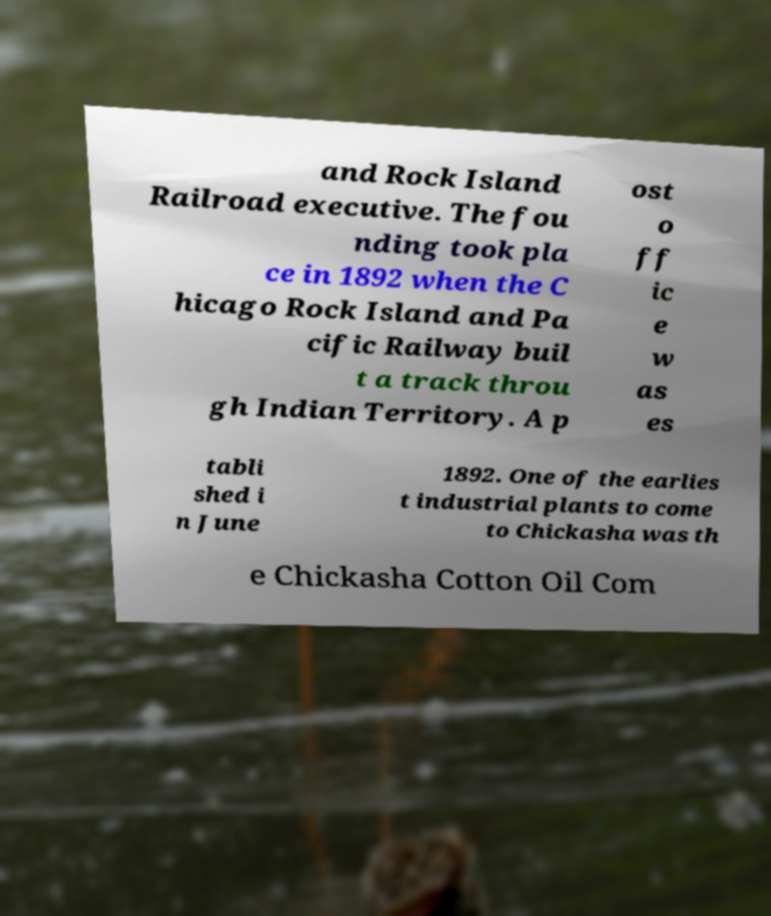What messages or text are displayed in this image? I need them in a readable, typed format. and Rock Island Railroad executive. The fou nding took pla ce in 1892 when the C hicago Rock Island and Pa cific Railway buil t a track throu gh Indian Territory. A p ost o ff ic e w as es tabli shed i n June 1892. One of the earlies t industrial plants to come to Chickasha was th e Chickasha Cotton Oil Com 